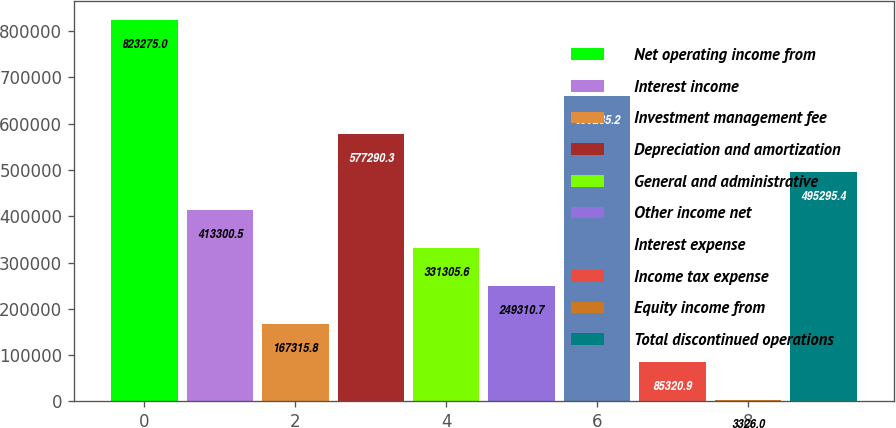<chart> <loc_0><loc_0><loc_500><loc_500><bar_chart><fcel>Net operating income from<fcel>Interest income<fcel>Investment management fee<fcel>Depreciation and amortization<fcel>General and administrative<fcel>Other income net<fcel>Interest expense<fcel>Income tax expense<fcel>Equity income from<fcel>Total discontinued operations<nl><fcel>823275<fcel>413300<fcel>167316<fcel>577290<fcel>331306<fcel>249311<fcel>659285<fcel>85320.9<fcel>3326<fcel>495295<nl></chart> 